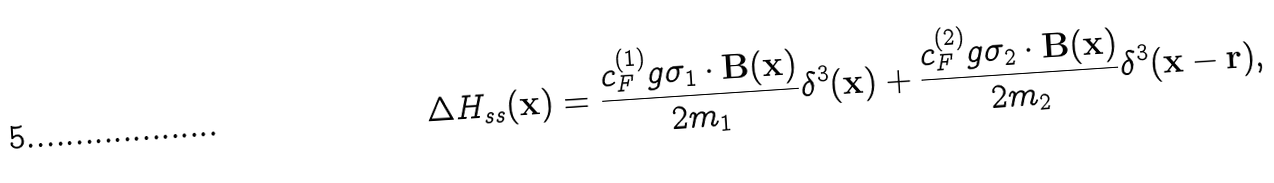Convert formula to latex. <formula><loc_0><loc_0><loc_500><loc_500>\Delta H _ { s s } ( { \mathbf x } ) = \frac { c _ { F } ^ { ( 1 ) } g { \mathbf \sigma _ { 1 } } \cdot { \mathbf B } ( { \mathbf x } ) } { 2 m _ { 1 } } \delta ^ { 3 } ( { \mathbf x } ) + \frac { c _ { F } ^ { ( 2 ) } g { \mathbf \sigma _ { 2 } } \cdot { \mathbf B } ( { \mathbf x } ) } { 2 m _ { 2 } } \delta ^ { 3 } ( { \mathbf x } - { \mathbf r } ) ,</formula> 